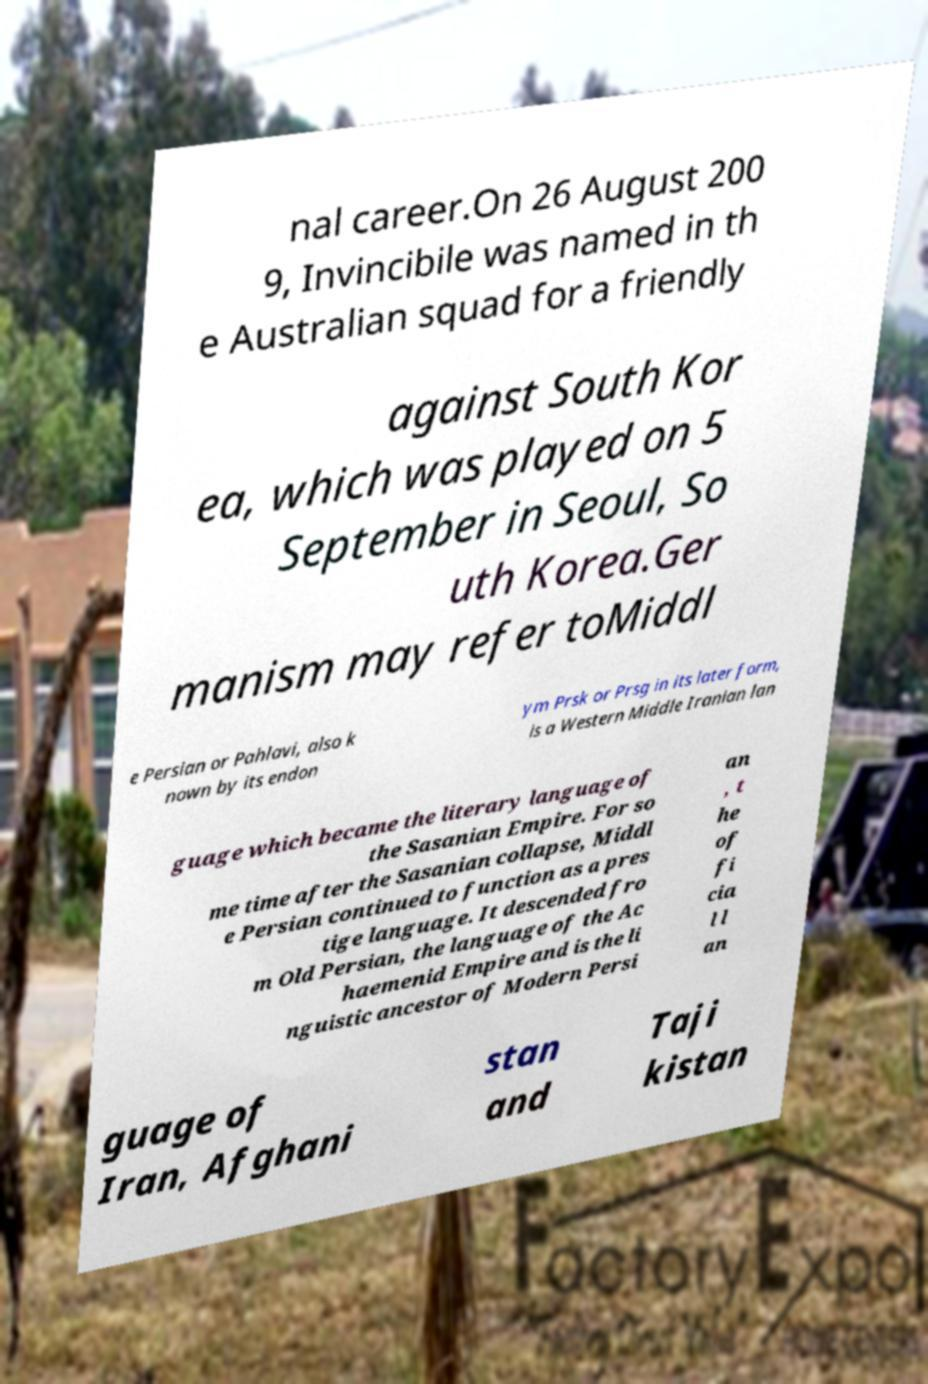For documentation purposes, I need the text within this image transcribed. Could you provide that? nal career.On 26 August 200 9, Invincibile was named in th e Australian squad for a friendly against South Kor ea, which was played on 5 September in Seoul, So uth Korea.Ger manism may refer toMiddl e Persian or Pahlavi, also k nown by its endon ym Prsk or Prsg in its later form, is a Western Middle Iranian lan guage which became the literary language of the Sasanian Empire. For so me time after the Sasanian collapse, Middl e Persian continued to function as a pres tige language. It descended fro m Old Persian, the language of the Ac haemenid Empire and is the li nguistic ancestor of Modern Persi an , t he of fi cia l l an guage of Iran, Afghani stan and Taji kistan 